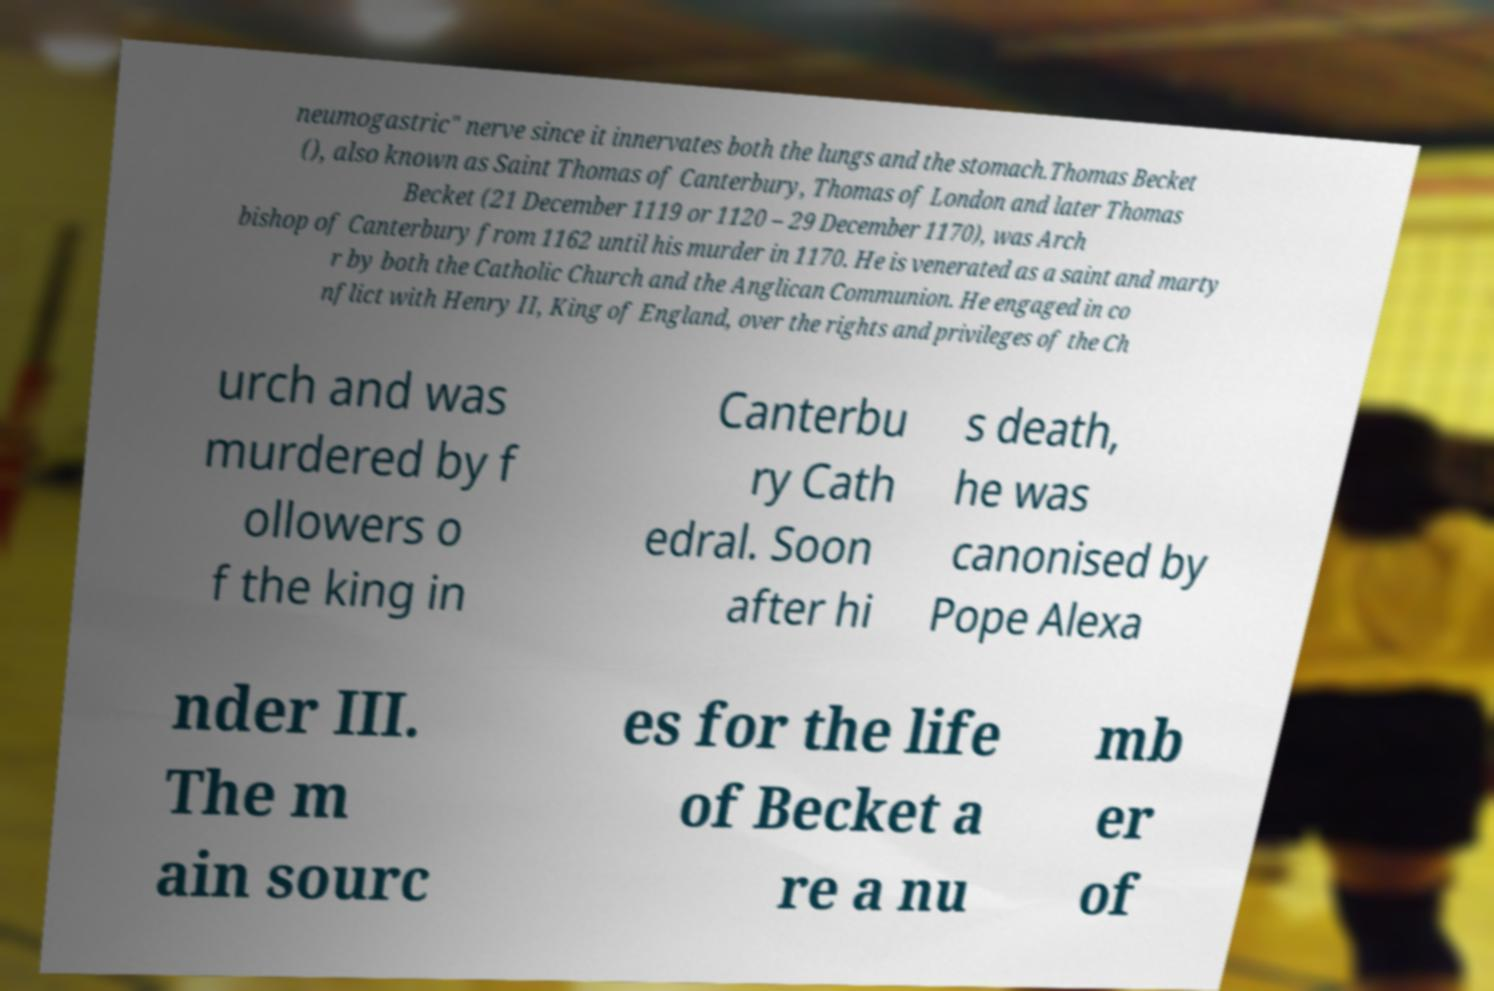For documentation purposes, I need the text within this image transcribed. Could you provide that? neumogastric" nerve since it innervates both the lungs and the stomach.Thomas Becket (), also known as Saint Thomas of Canterbury, Thomas of London and later Thomas Becket (21 December 1119 or 1120 – 29 December 1170), was Arch bishop of Canterbury from 1162 until his murder in 1170. He is venerated as a saint and marty r by both the Catholic Church and the Anglican Communion. He engaged in co nflict with Henry II, King of England, over the rights and privileges of the Ch urch and was murdered by f ollowers o f the king in Canterbu ry Cath edral. Soon after hi s death, he was canonised by Pope Alexa nder III. The m ain sourc es for the life of Becket a re a nu mb er of 